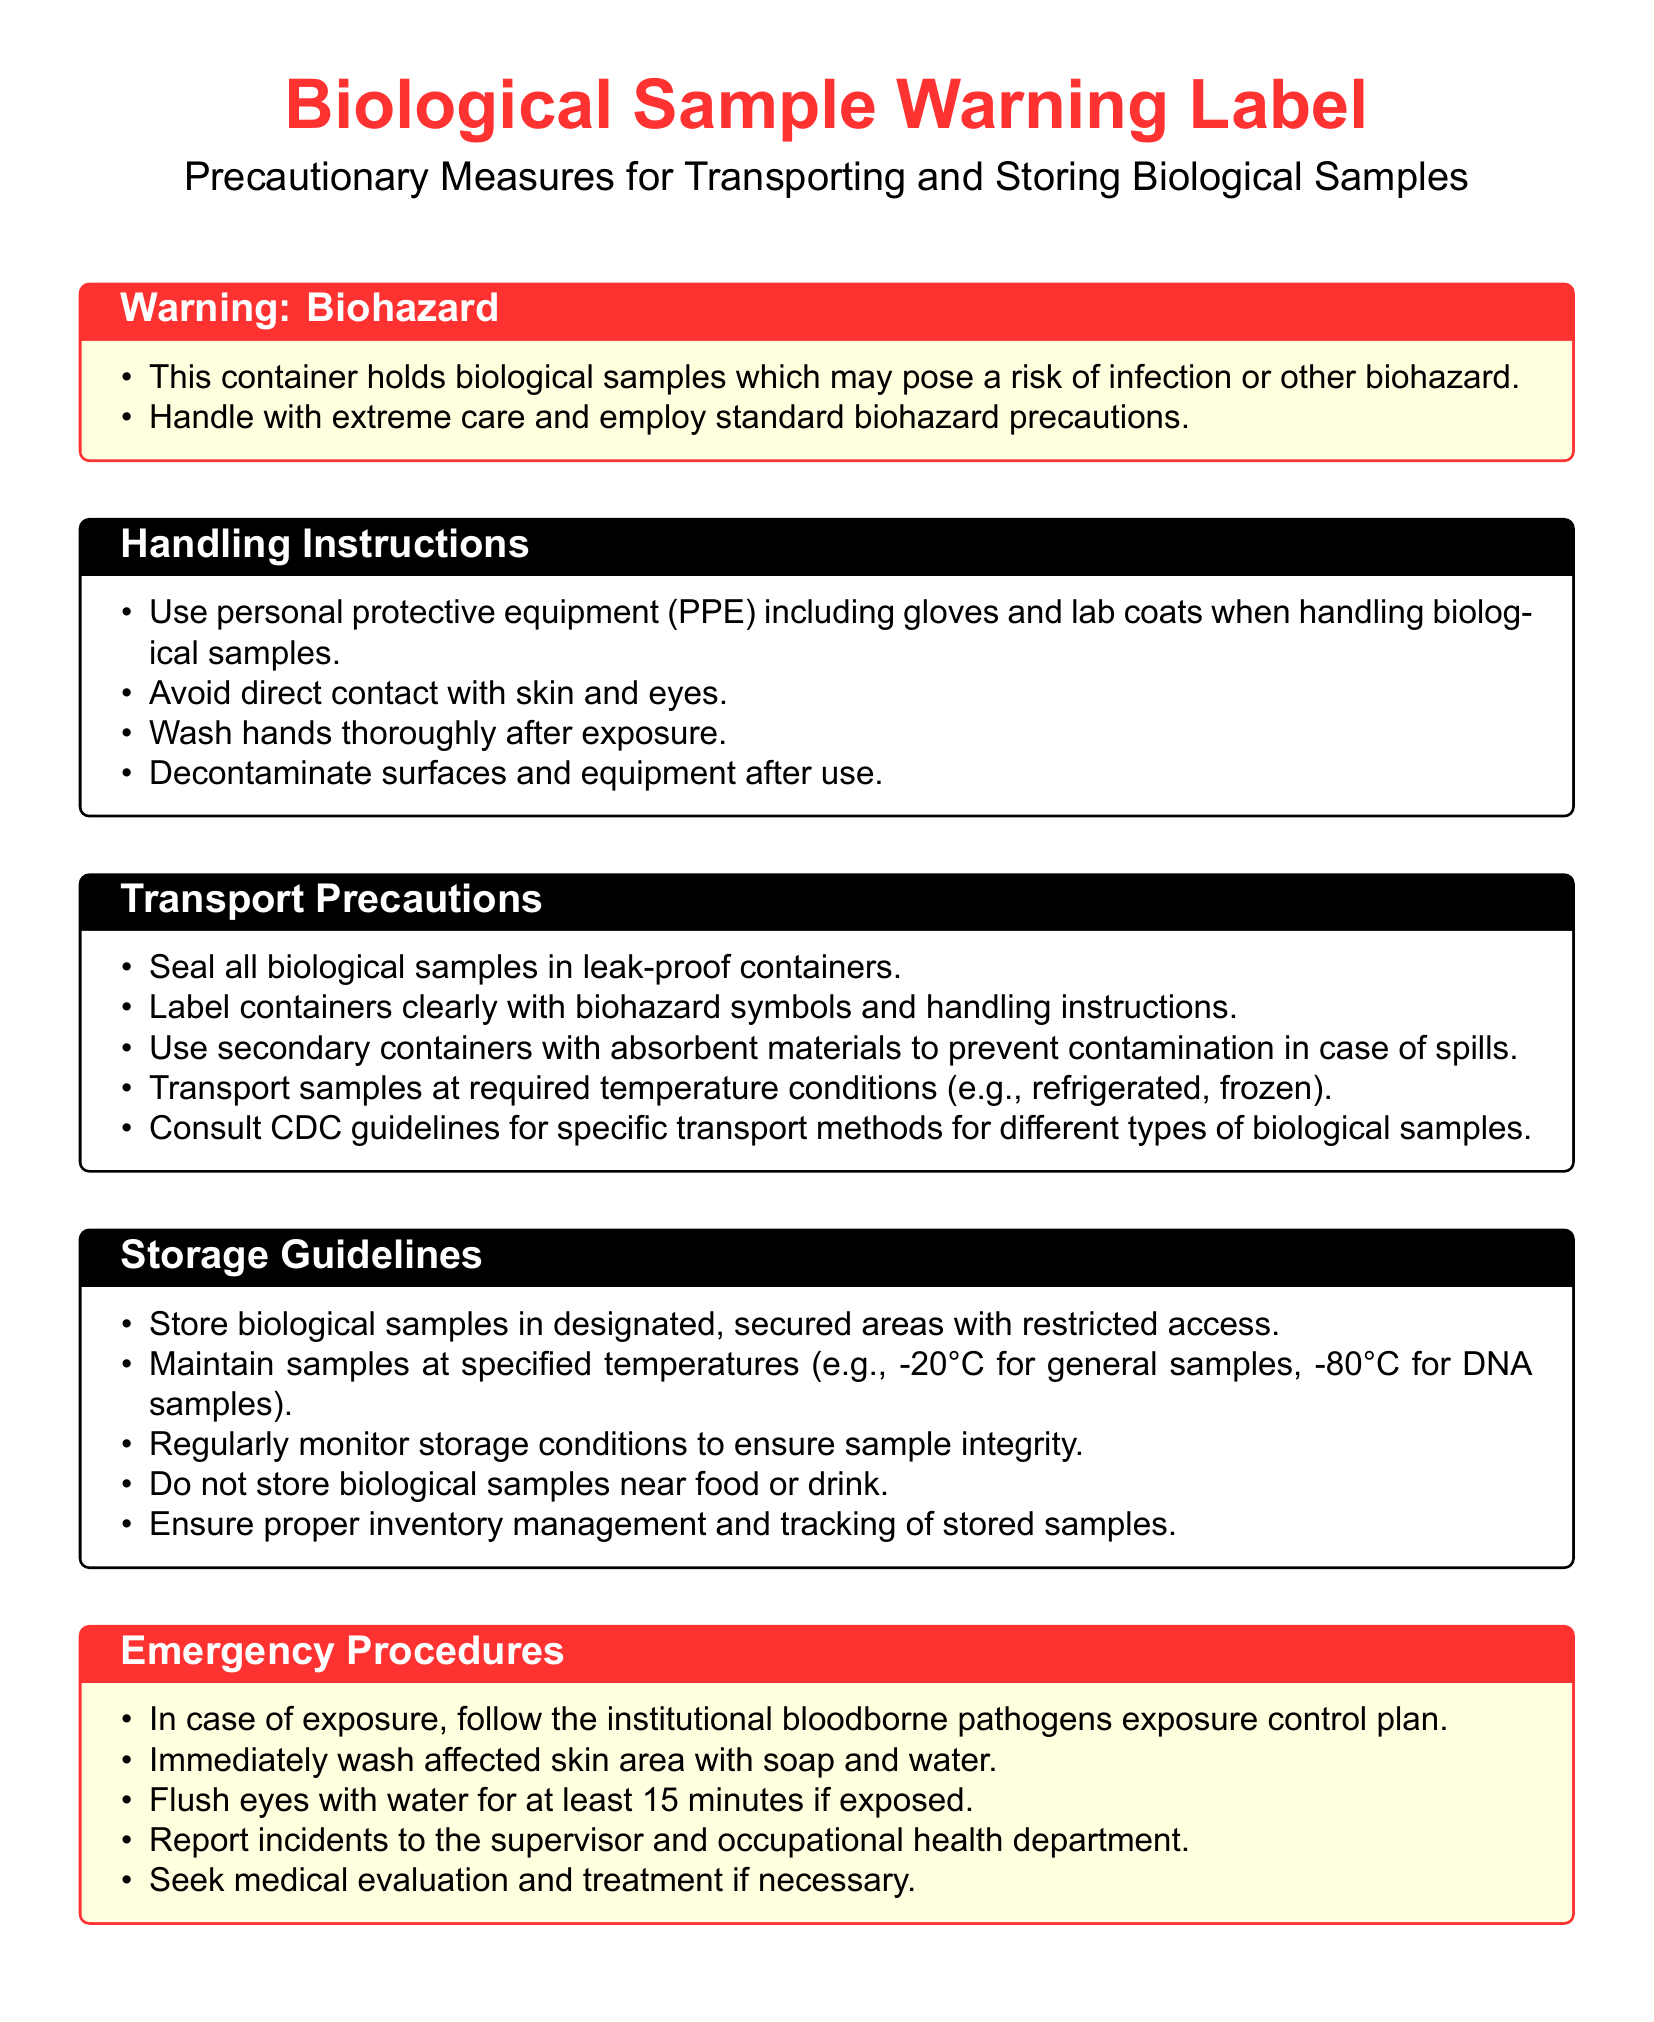What is the main risk associated with the biological samples? The document states that biological samples may pose a risk of infection or other biohazard.
Answer: Infection or biohazard What equipment is recommended for handling biological samples? The handling instructions suggest the use of personal protective equipment such as gloves and lab coats.
Answer: PPE (gloves and lab coats) What temperature should general biological samples be stored at? The storage guidelines specify that general samples should be maintained at -20°C.
Answer: -20°C What should be done immediately after exposure to biological samples? The emergency procedures recommend washing the affected skin area with soap and water.
Answer: Wash with soap and water What symbol should be labeled on containers for biological samples? The document indicates that containers should be labeled with biohazard symbols.
Answer: Biohazard symbols Why is it important to monitor storage conditions? The storage guidelines emphasize ensuring sample integrity through regular monitoring of storage conditions.
Answer: Ensure sample integrity What is a key transport precaution stated in the document? One key precaution is to seal all biological samples in leak-proof containers during transport.
Answer: Seal in leak-proof containers What action should be taken if eyes are exposed to biological samples? The emergency procedures instruct to flush eyes with water for at least 15 minutes if exposed.
Answer: Flush eyes with water How should surfaces be treated after handling biological samples? The handling instructions advise decontaminating surfaces and equipment after use.
Answer: Decontaminate surfaces and equipment 